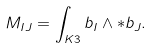Convert formula to latex. <formula><loc_0><loc_0><loc_500><loc_500>M _ { I J } = \int _ { K 3 } b _ { I } \wedge \ast b _ { J } .</formula> 